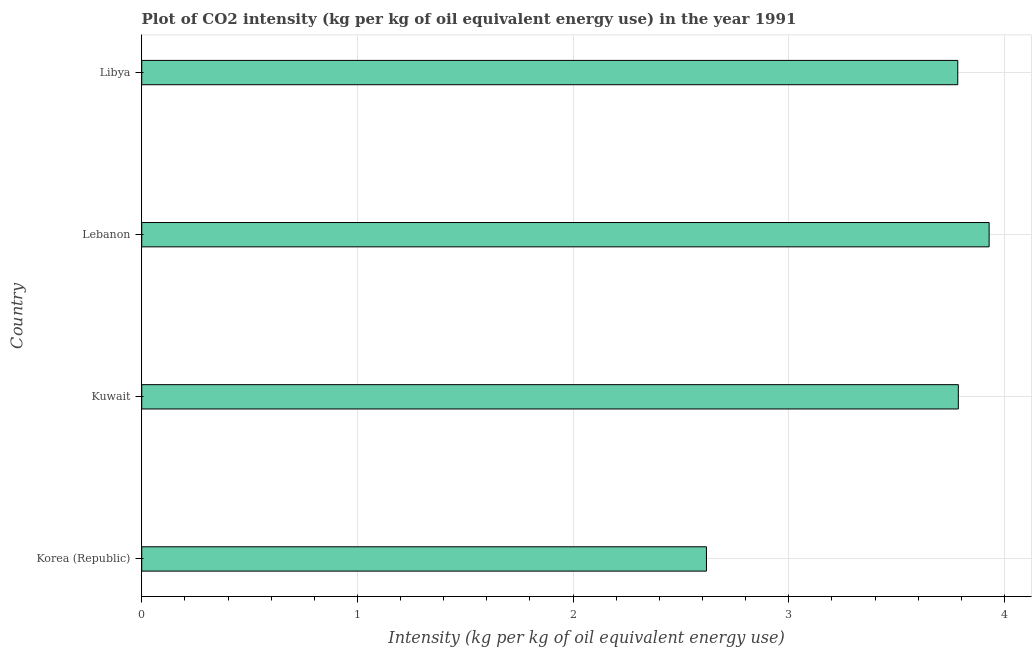What is the title of the graph?
Your answer should be very brief. Plot of CO2 intensity (kg per kg of oil equivalent energy use) in the year 1991. What is the label or title of the X-axis?
Make the answer very short. Intensity (kg per kg of oil equivalent energy use). What is the co2 intensity in Korea (Republic)?
Your answer should be compact. 2.62. Across all countries, what is the maximum co2 intensity?
Offer a very short reply. 3.93. Across all countries, what is the minimum co2 intensity?
Offer a very short reply. 2.62. In which country was the co2 intensity maximum?
Make the answer very short. Lebanon. What is the sum of the co2 intensity?
Offer a very short reply. 14.12. What is the difference between the co2 intensity in Korea (Republic) and Lebanon?
Give a very brief answer. -1.31. What is the average co2 intensity per country?
Give a very brief answer. 3.53. What is the median co2 intensity?
Keep it short and to the point. 3.78. What is the ratio of the co2 intensity in Korea (Republic) to that in Libya?
Your response must be concise. 0.69. Is the difference between the co2 intensity in Korea (Republic) and Libya greater than the difference between any two countries?
Ensure brevity in your answer.  No. What is the difference between the highest and the second highest co2 intensity?
Your response must be concise. 0.14. What is the difference between the highest and the lowest co2 intensity?
Your response must be concise. 1.31. In how many countries, is the co2 intensity greater than the average co2 intensity taken over all countries?
Keep it short and to the point. 3. How many bars are there?
Your answer should be compact. 4. What is the Intensity (kg per kg of oil equivalent energy use) of Korea (Republic)?
Make the answer very short. 2.62. What is the Intensity (kg per kg of oil equivalent energy use) of Kuwait?
Your answer should be very brief. 3.79. What is the Intensity (kg per kg of oil equivalent energy use) of Lebanon?
Your answer should be very brief. 3.93. What is the Intensity (kg per kg of oil equivalent energy use) in Libya?
Provide a succinct answer. 3.78. What is the difference between the Intensity (kg per kg of oil equivalent energy use) in Korea (Republic) and Kuwait?
Ensure brevity in your answer.  -1.17. What is the difference between the Intensity (kg per kg of oil equivalent energy use) in Korea (Republic) and Lebanon?
Ensure brevity in your answer.  -1.31. What is the difference between the Intensity (kg per kg of oil equivalent energy use) in Korea (Republic) and Libya?
Your answer should be very brief. -1.17. What is the difference between the Intensity (kg per kg of oil equivalent energy use) in Kuwait and Lebanon?
Your answer should be very brief. -0.14. What is the difference between the Intensity (kg per kg of oil equivalent energy use) in Kuwait and Libya?
Offer a terse response. 0. What is the difference between the Intensity (kg per kg of oil equivalent energy use) in Lebanon and Libya?
Your answer should be compact. 0.15. What is the ratio of the Intensity (kg per kg of oil equivalent energy use) in Korea (Republic) to that in Kuwait?
Your answer should be compact. 0.69. What is the ratio of the Intensity (kg per kg of oil equivalent energy use) in Korea (Republic) to that in Lebanon?
Your answer should be compact. 0.67. What is the ratio of the Intensity (kg per kg of oil equivalent energy use) in Korea (Republic) to that in Libya?
Keep it short and to the point. 0.69. What is the ratio of the Intensity (kg per kg of oil equivalent energy use) in Kuwait to that in Libya?
Ensure brevity in your answer.  1. What is the ratio of the Intensity (kg per kg of oil equivalent energy use) in Lebanon to that in Libya?
Your answer should be very brief. 1.04. 